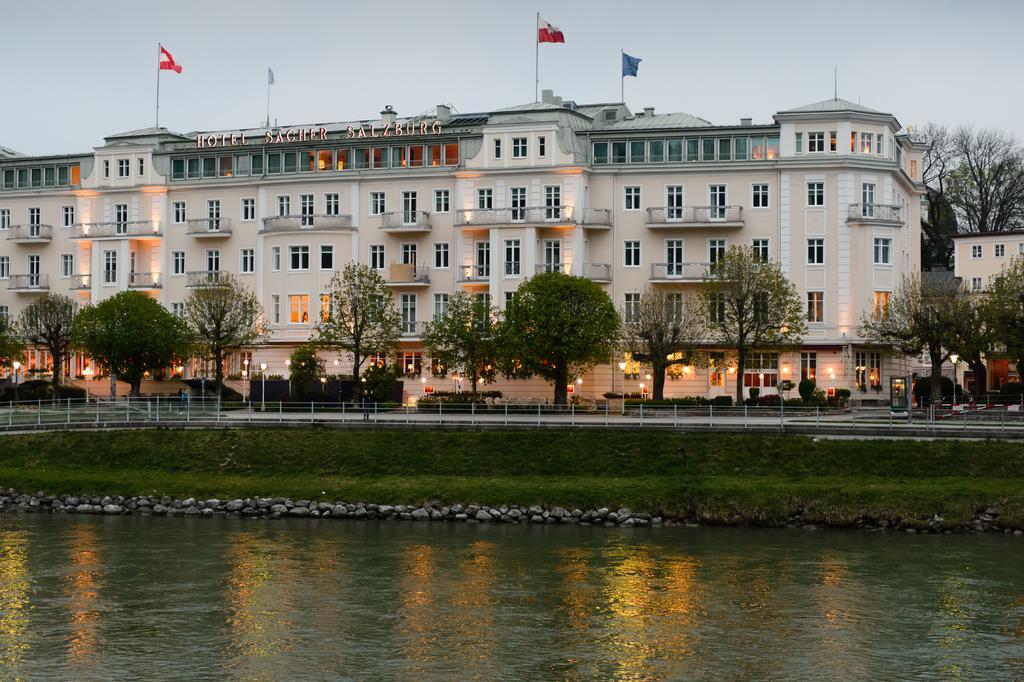Can you describe this image briefly? In this image we can see a building with windows, signboard and the flags. We can also see a fence, a group of trees, street lamps, grass, stones, a water body and the sky which looks cloudy. 